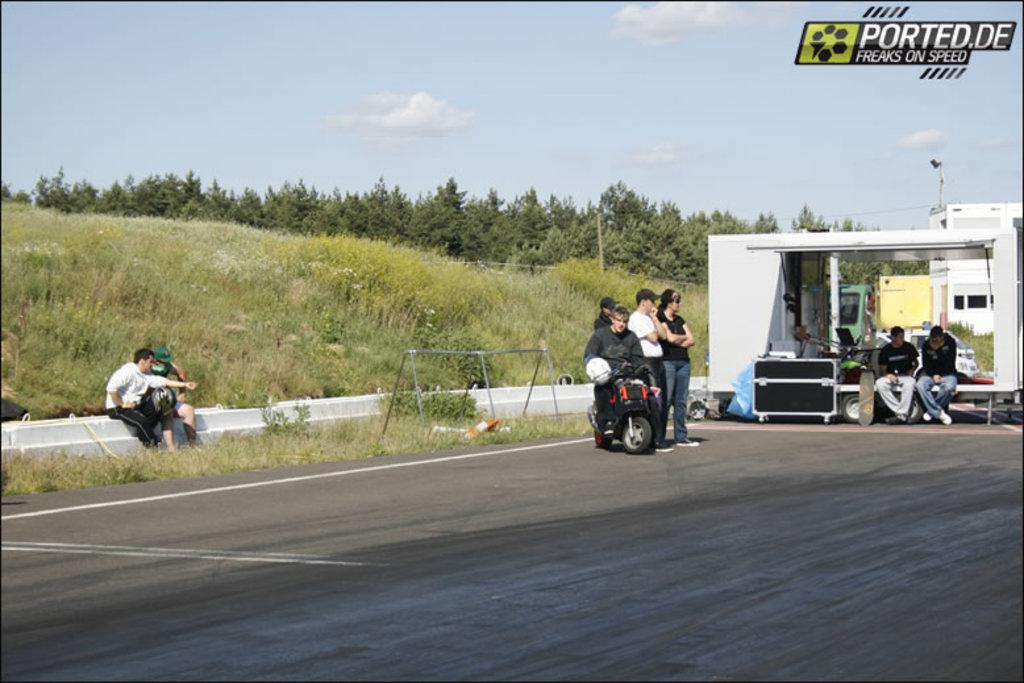How many people are present in the image? There are people in the image, but the exact number is not specified. What type of structure can be seen in the image? There is a building in the image. What object is present that could be used for storage or transportation? There is a box and a vehicle in the image. What type of natural environment is visible in the image? There is grass in the image. What can be seen in the background of the image? There are trees and clouds visible in the image. What type of wine is being served in the image? There is no wine present in the image. Can you tell me how many horses are visible in the image? There are no horses present in the image. 